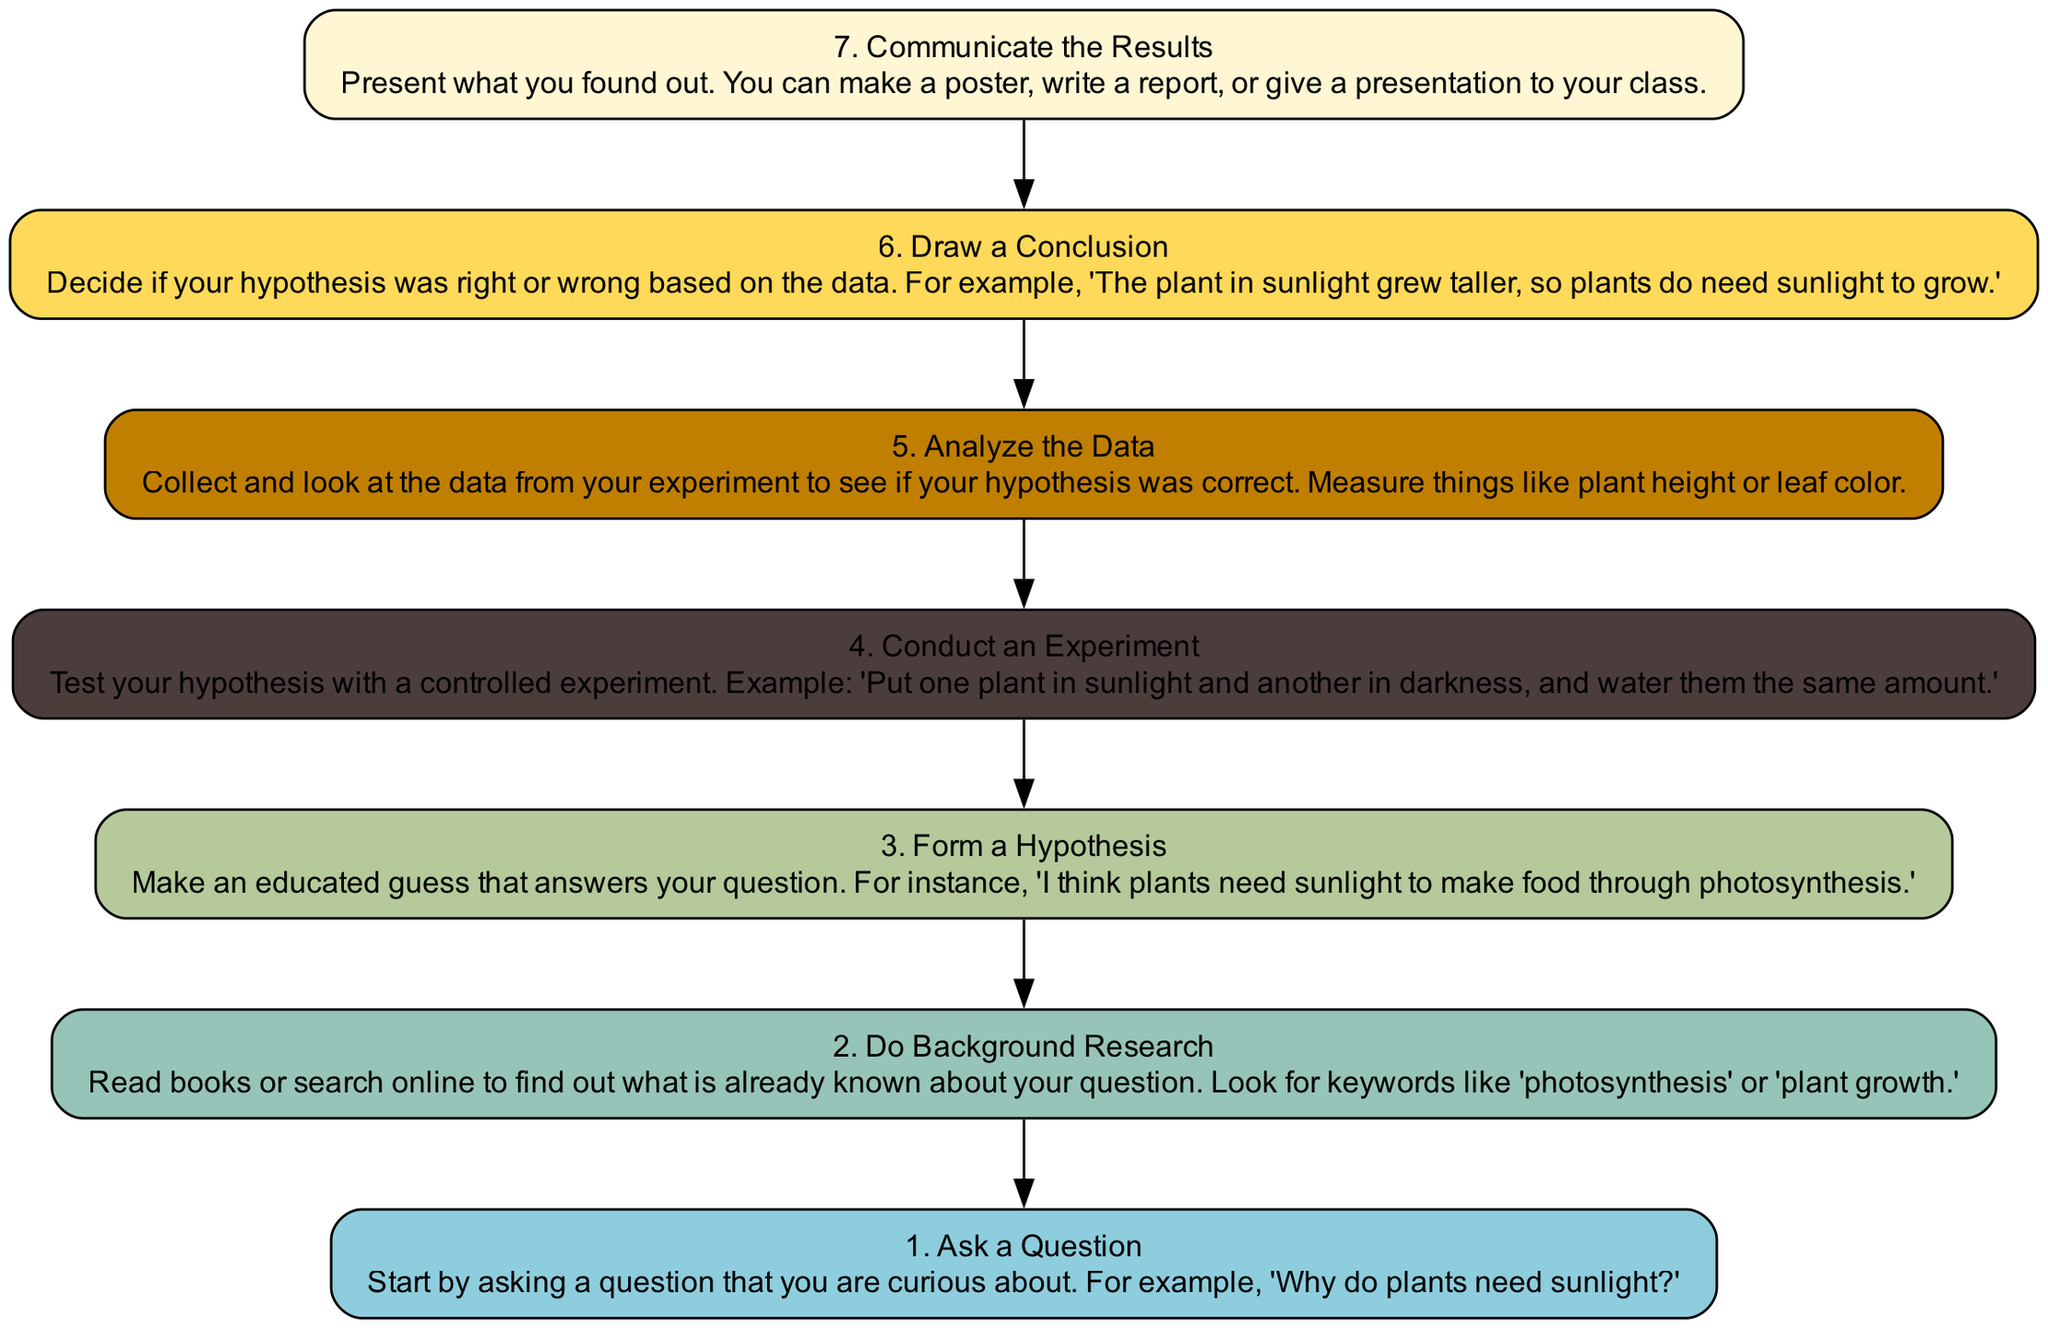What is the first step in the scientific method? The first step in the diagram is "Ask a Question". It is listed at the bottom of the flow chart, signifying the start of the process.
Answer: Ask a Question How many steps are in the scientific method? The diagram includes a total of 7 steps, as evidenced by each numbered item from 1 to 7 listed in the flow chart.
Answer: 7 What step comes after "Conduct an Experiment"? After reviewing the nodes, "Analyze the Data" follows "Conduct an Experiment", which shows the progression in the method.
Answer: Analyze the Data What is the main purpose of the step "Draw a Conclusion"? This step's purpose is to determine if the hypothesis was correct based on the data collected during the experiment. Hence, it directly relates to assessing the results.
Answer: To determine if the hypothesis was correct Which step involves gathering knowledge about the experiment topic? The "Do Background Research" step is focused specifically on collecting existing information related to the question being investigated.
Answer: Do Background Research What relationship exists between "Form a Hypothesis" and "Conduct an Experiment"? "Form a Hypothesis" is a prerequisite for "Conduct an Experiment", indicating that the experiment is designed to test the hypothesis that was previously stated.
Answer: Sequential relationship What must you do after analyzing the data? After analyzing the data, you need to "Draw a Conclusion", as this is the next logical step to interpret the findings.
Answer: Draw a Conclusion How can you communicate your results? The diagram outlines that results can be communicated through methods such as making a poster, writing a report, or giving a presentation to your class.
Answer: Make a poster, write a report, or give a presentation 